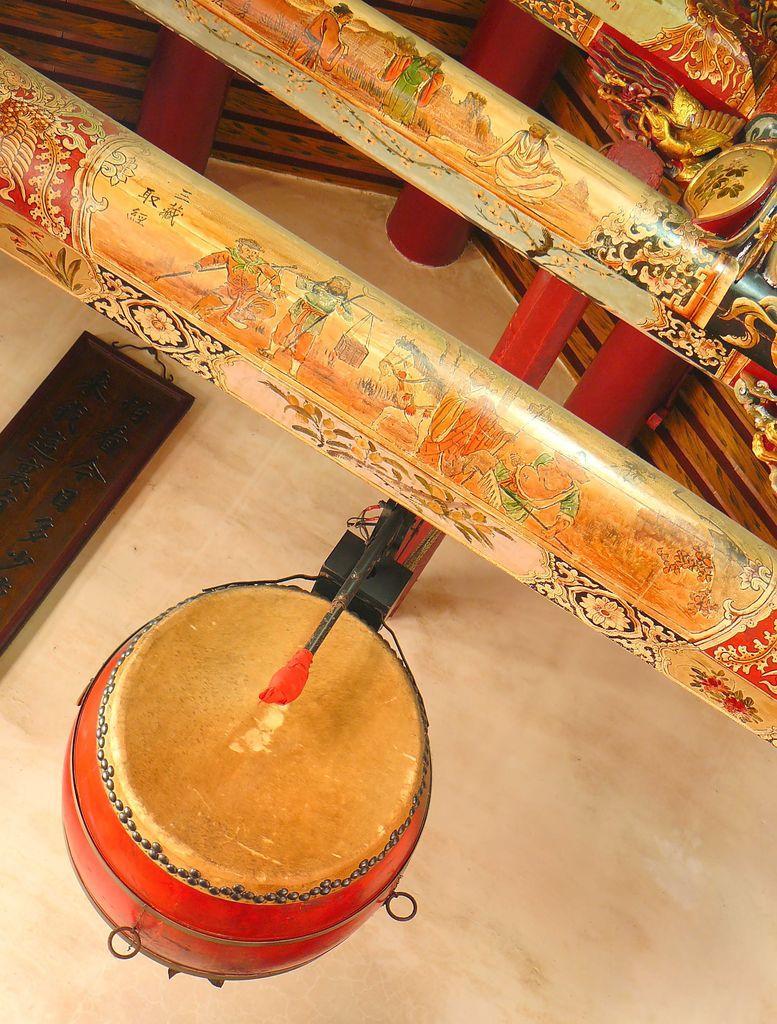Can you describe this image briefly? At the bottom of the picture, we see a drum in red color. Beside that, there are pillars and behind that, we see a white wall and we even see a brown board with some text written on it, is placed on the wall. Beside that, we see a wall in brown color and we even see red color rods. 